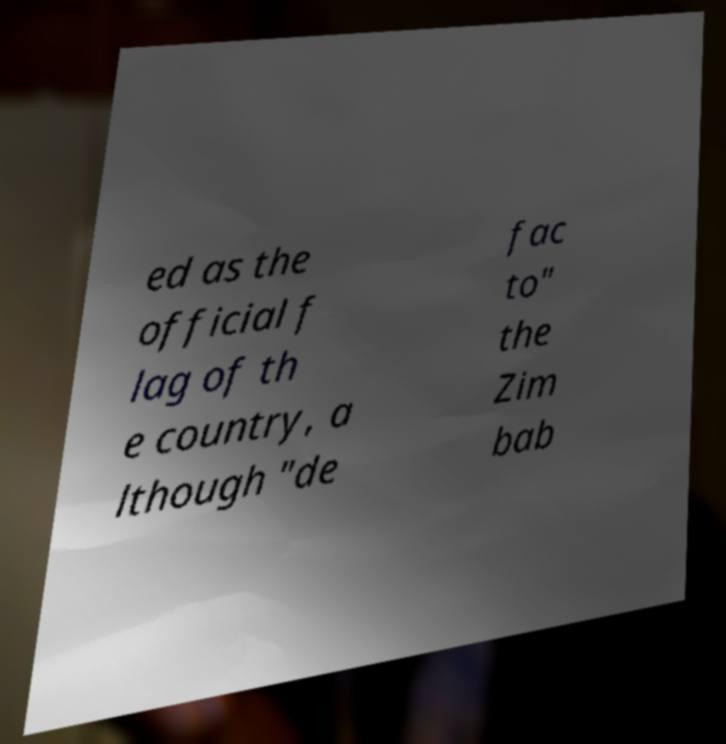There's text embedded in this image that I need extracted. Can you transcribe it verbatim? ed as the official f lag of th e country, a lthough "de fac to" the Zim bab 